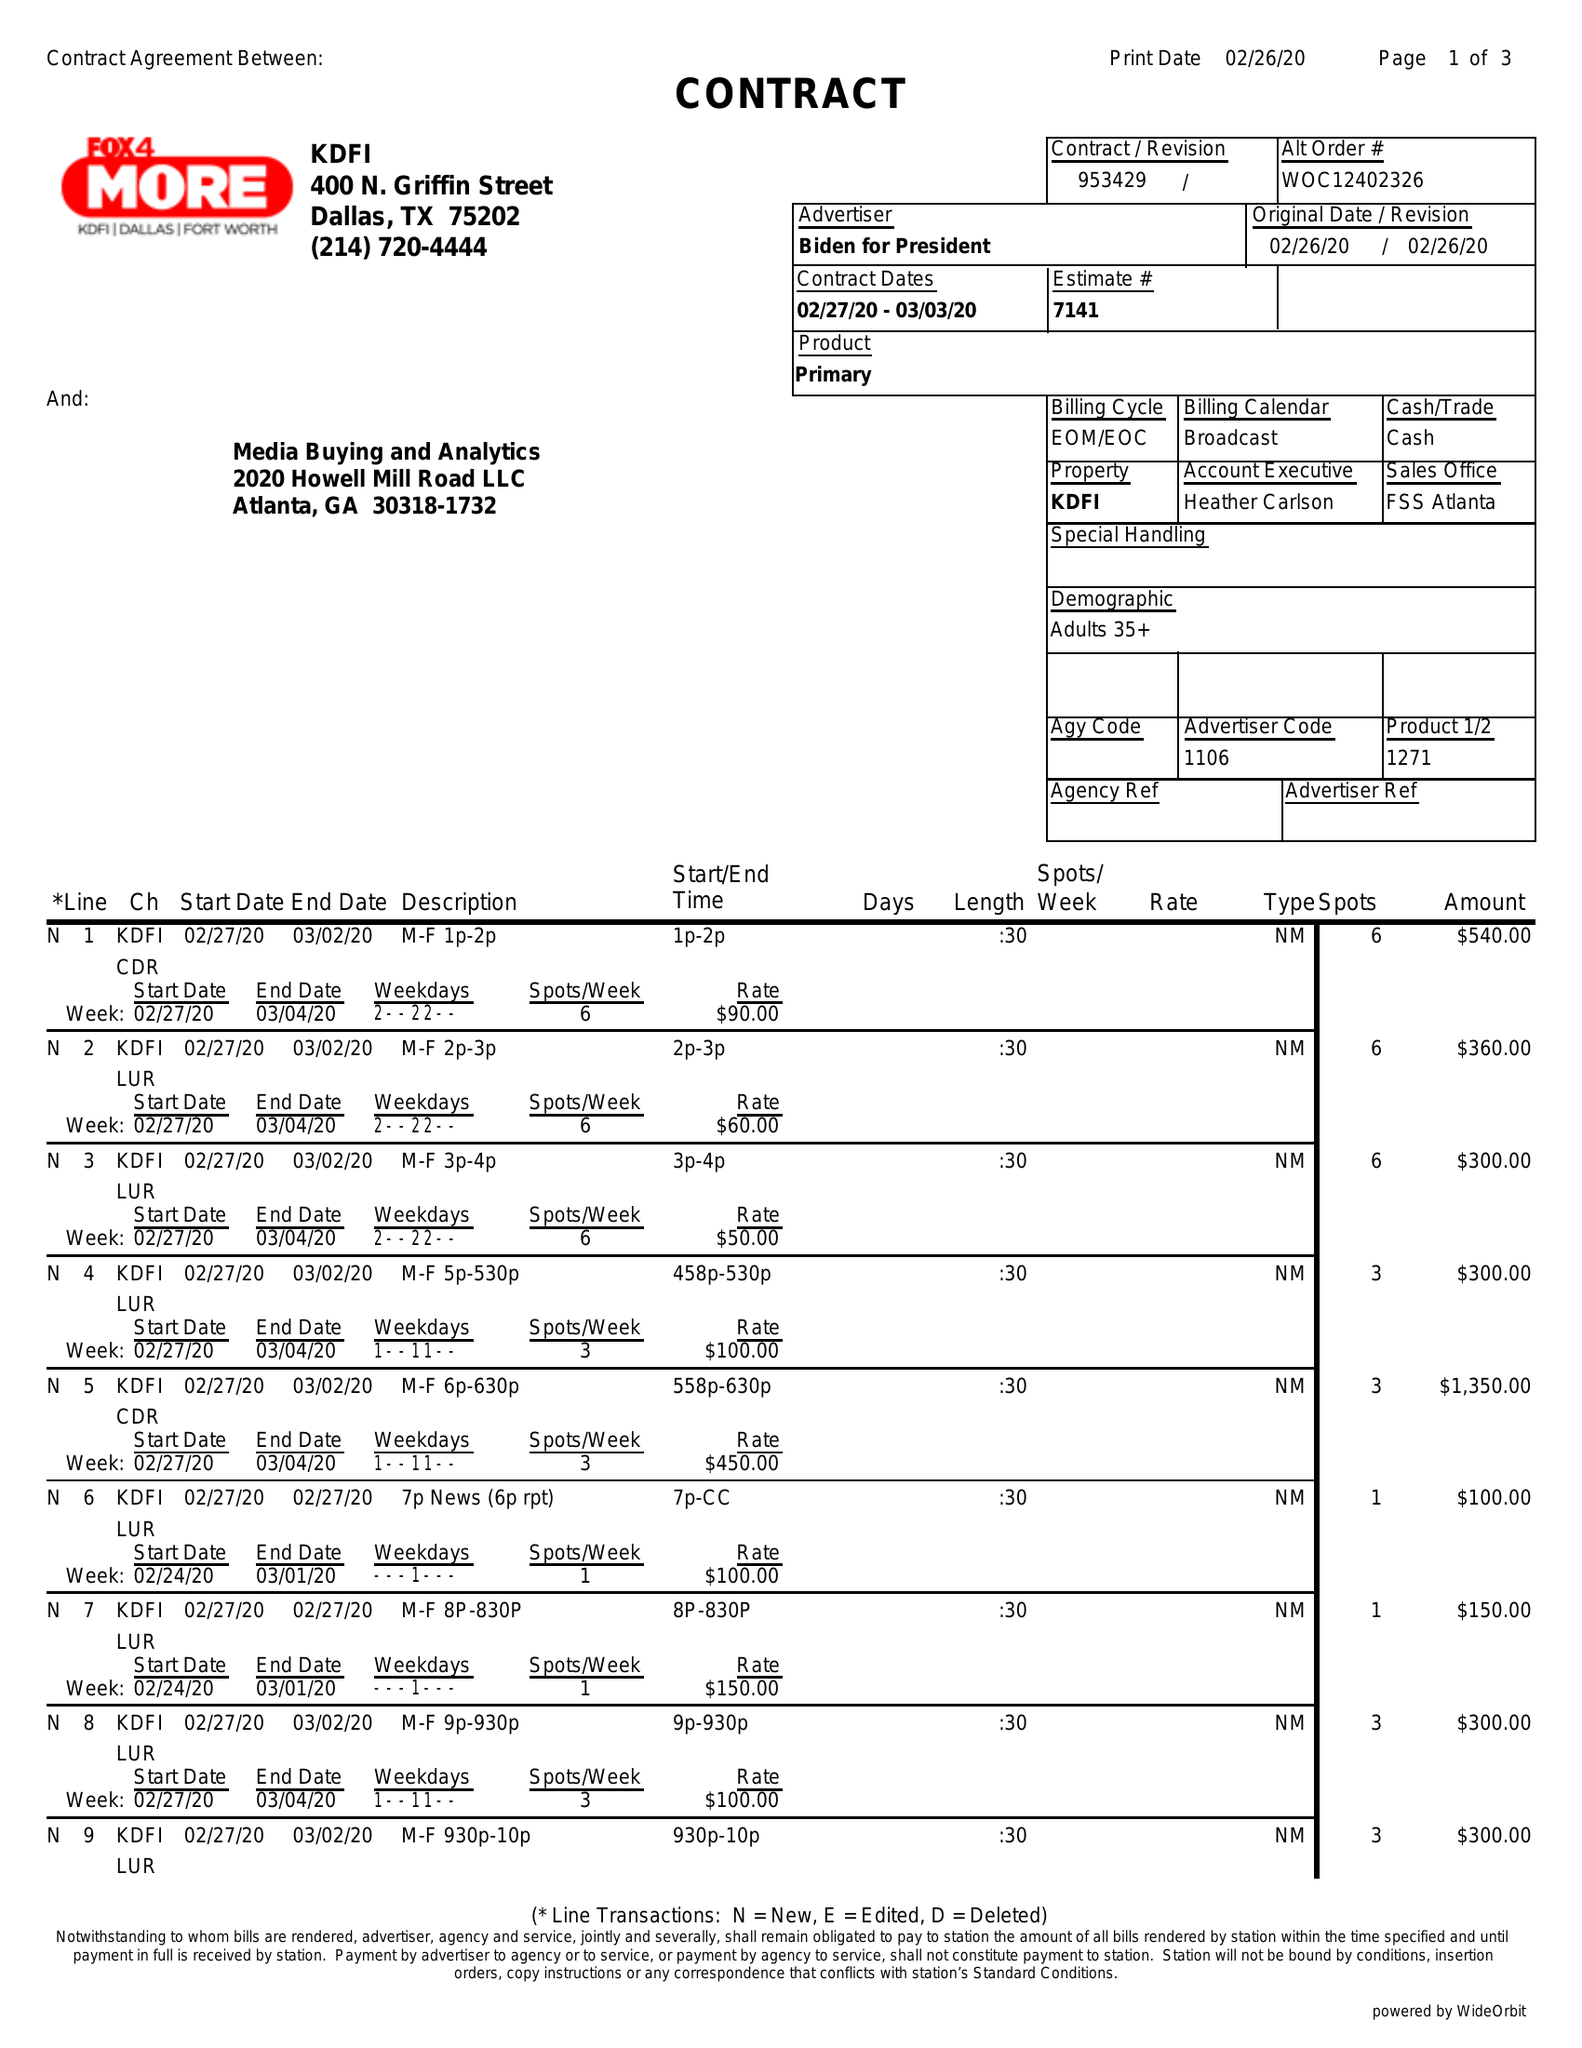What is the value for the flight_to?
Answer the question using a single word or phrase. 02/26/20 